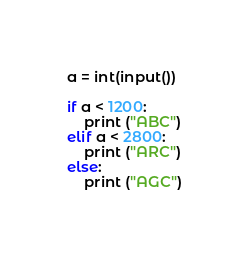<code> <loc_0><loc_0><loc_500><loc_500><_Python_>a = int(input())

if a < 1200:
    print ("ABC")
elif a < 2800:
    print ("ARC")
else:
    print ("AGC")</code> 